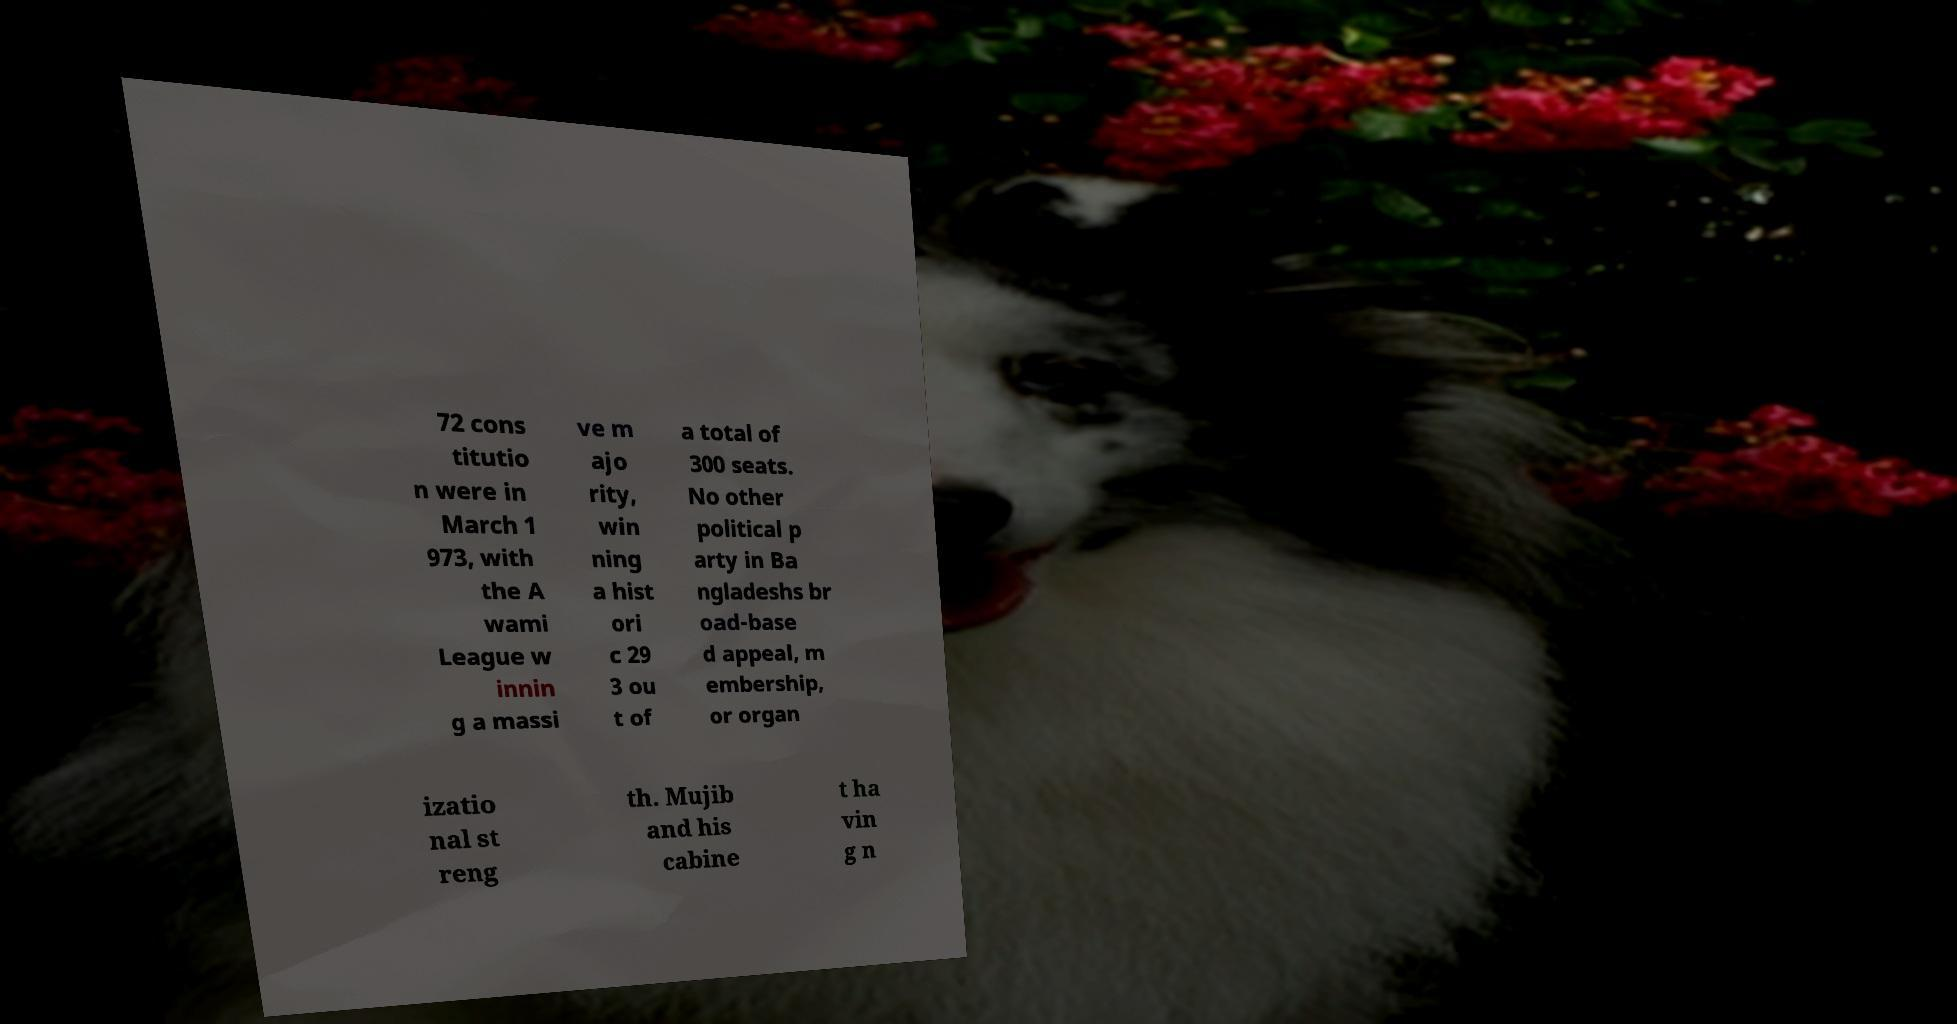Can you read and provide the text displayed in the image?This photo seems to have some interesting text. Can you extract and type it out for me? 72 cons titutio n were in March 1 973, with the A wami League w innin g a massi ve m ajo rity, win ning a hist ori c 29 3 ou t of a total of 300 seats. No other political p arty in Ba ngladeshs br oad-base d appeal, m embership, or organ izatio nal st reng th. Mujib and his cabine t ha vin g n 